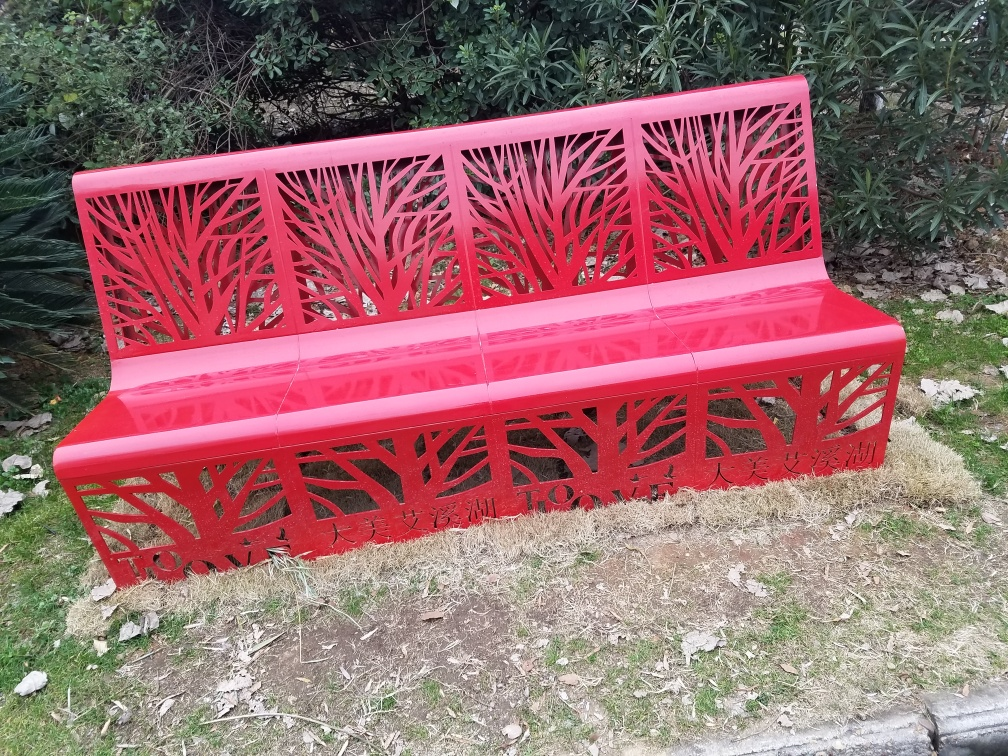Is there any noise in the image? No audible noise is present in the image, as it is a static visual representation. However, the image displays a vibrant red bench with intricate cut-out patterns resembling trees which does not show any visual 'noise' or distortion, providing a clear and aesthetically pleasing view. 